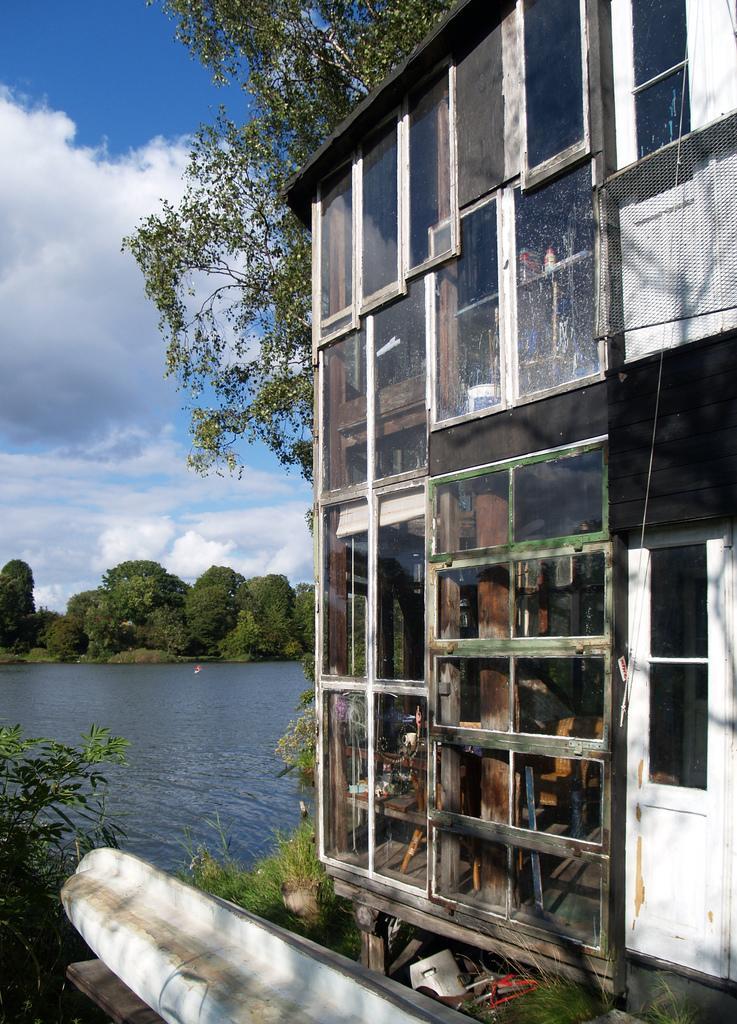How would you summarize this image in a sentence or two? In the picture house building on the bank of the water with a glass window and besides, we can see some plants and in the background, we can see water, and far away we can see some trees and sky with clouds. 